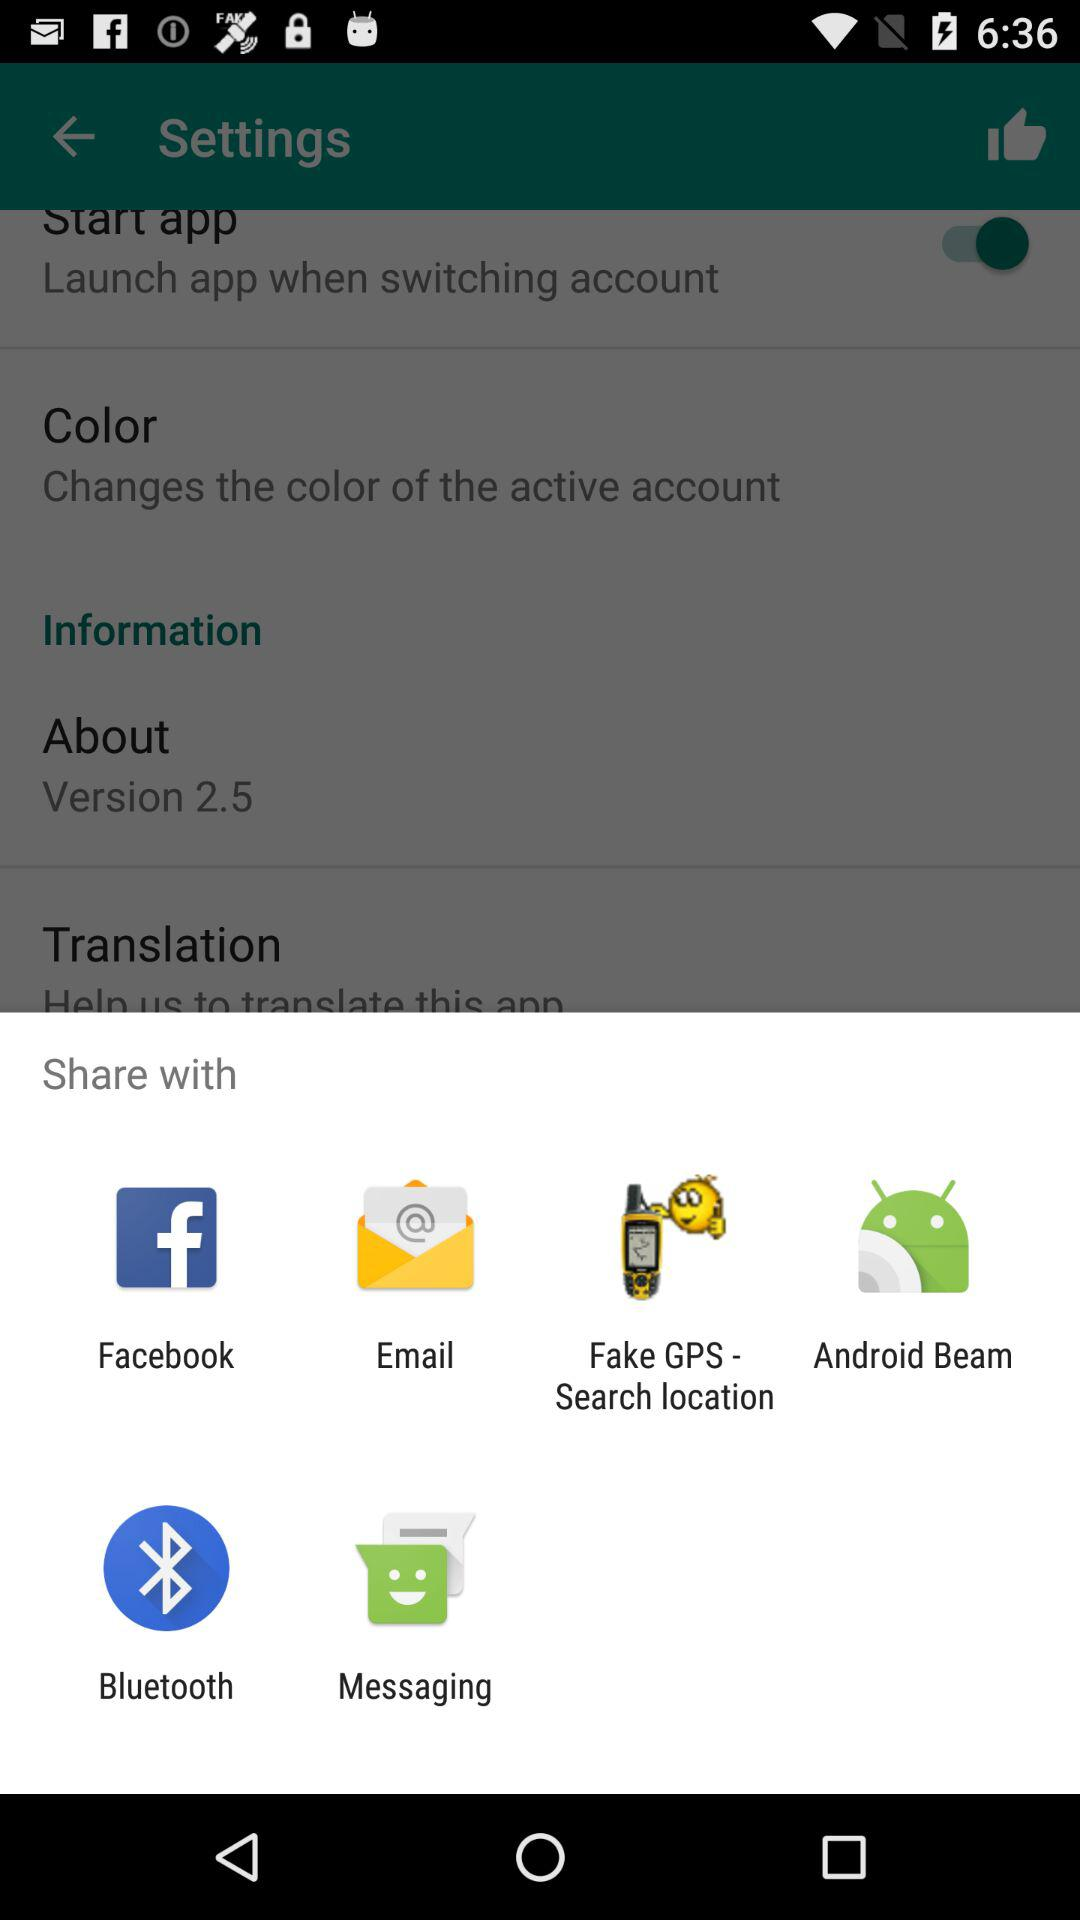What is the status of "Start app"? The status is "on". 